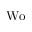<formula> <loc_0><loc_0><loc_500><loc_500>W o</formula> 